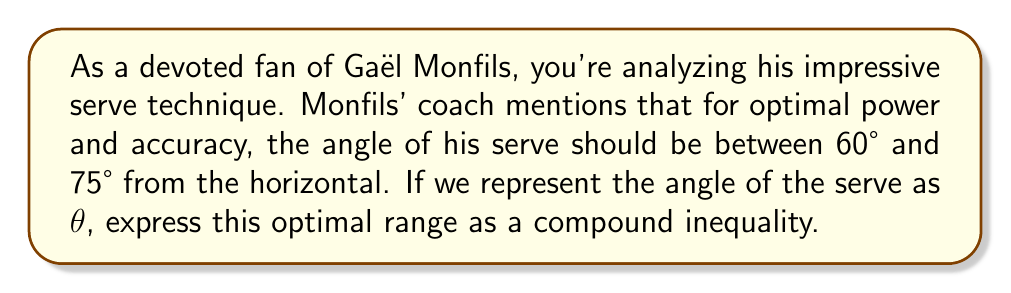Help me with this question. To solve this problem, we need to translate the given information into a mathematical inequality:

1. The lower bound of the angle is 60°.
2. The upper bound of the angle is 75°.
3. We use $\theta$ to represent the angle of the serve.

In mathematics, we can express a value being between two other values using a compound inequality. The general form is:

$$ \text{lower bound} < \text{variable} < \text{upper bound} $$

or

$$ \text{lower bound} \leq \text{variable} \leq \text{upper bound} $$

In this case, we want $\theta$ to be greater than or equal to 60° and less than or equal to 75°.

Therefore, we can express this as:

$$ 60° \leq \theta \leq 75° $$

This inequality means that the angle $\theta$ should be greater than or equal to 60° and less than or equal to 75° for optimal serve performance.
Answer: $$ 60° \leq \theta \leq 75° $$ 